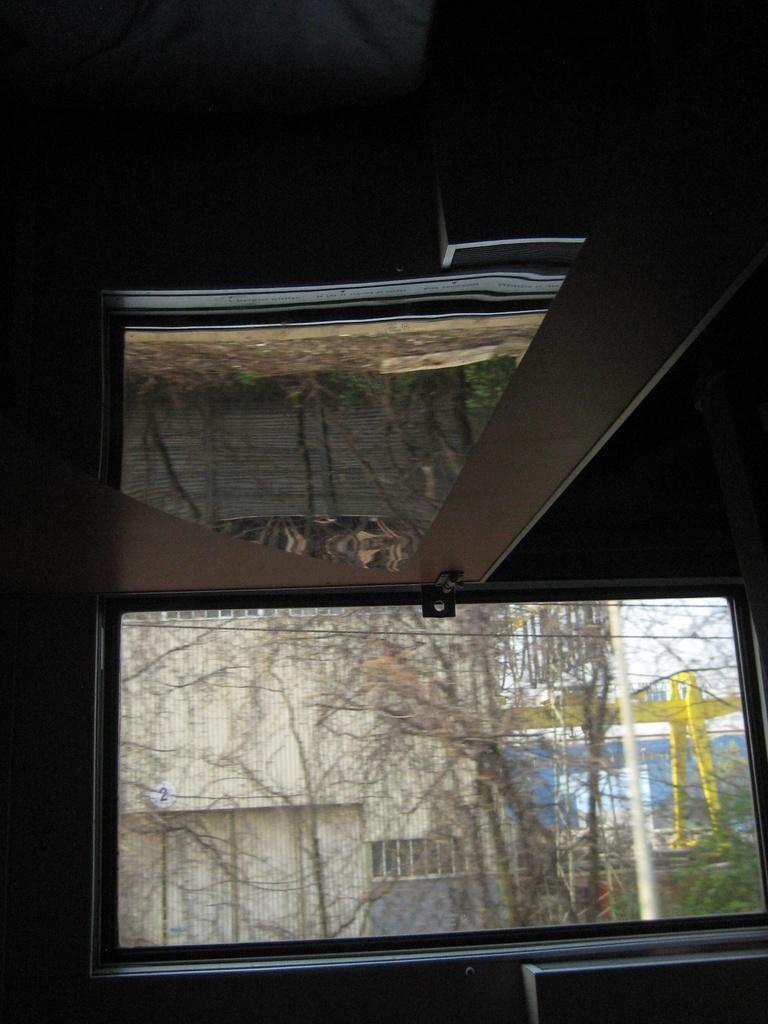What type of structure is visible in the image? There is a glass window in the image. What can be seen in the background of the image? There is a building and trees in the background of the image. How many geese are flying in the image? There are no geese present in the image. What type of animal can be seen grazing near the trees in the image? There are no animals visible in the image; only a building and trees can be seen in the background. 